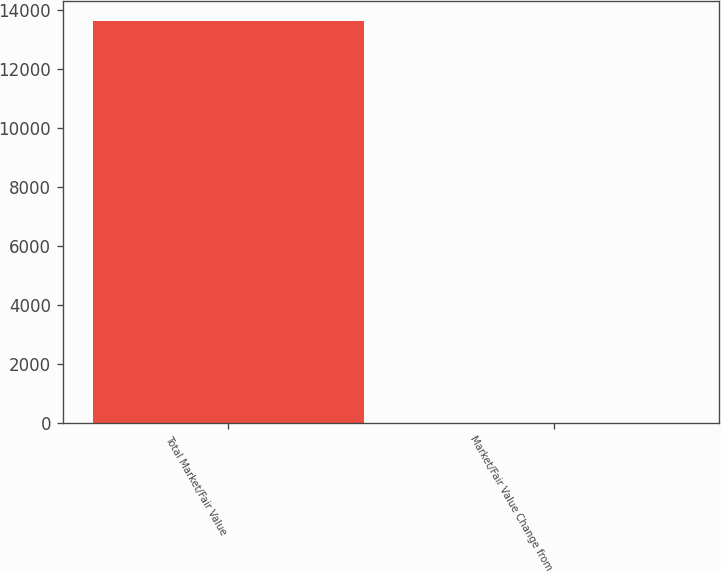Convert chart. <chart><loc_0><loc_0><loc_500><loc_500><bar_chart><fcel>Total Market/Fair Value<fcel>Market/Fair Value Change from<nl><fcel>13645.7<fcel>2.8<nl></chart> 